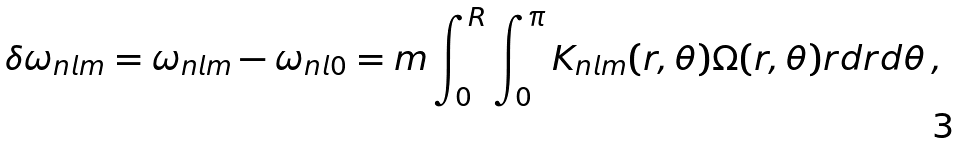Convert formula to latex. <formula><loc_0><loc_0><loc_500><loc_500>\delta \omega _ { n l m } = \omega _ { n l m } - \omega _ { n l 0 } = m \int _ { 0 } ^ { R } \int _ { 0 } ^ { \pi } K _ { n l m } ( r , \theta ) \Omega ( r , \theta ) r d r d \theta \, ,</formula> 